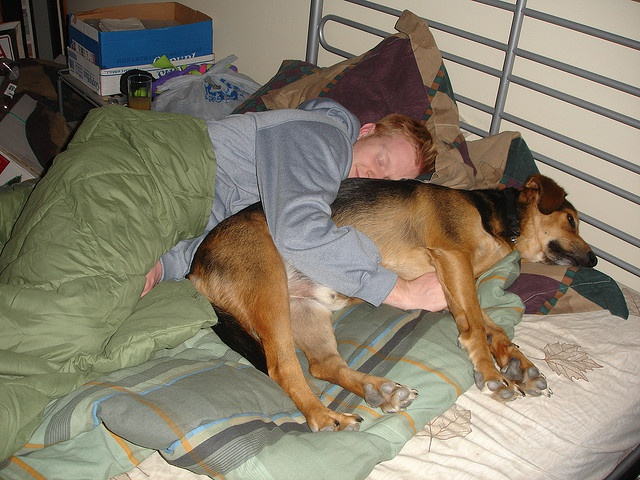Describe the objects in this image and their specific colors. I can see bed in gray, darkgray, black, and tan tones, dog in black, brown, tan, and gray tones, people in black, darkgray, gray, and salmon tones, cup in black, maroon, darkgreen, and gray tones, and book in black, gray, and maroon tones in this image. 